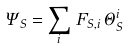Convert formula to latex. <formula><loc_0><loc_0><loc_500><loc_500>\Psi _ { S } = \sum _ { i } \, F _ { S , i } \, \Theta _ { S } ^ { i }</formula> 